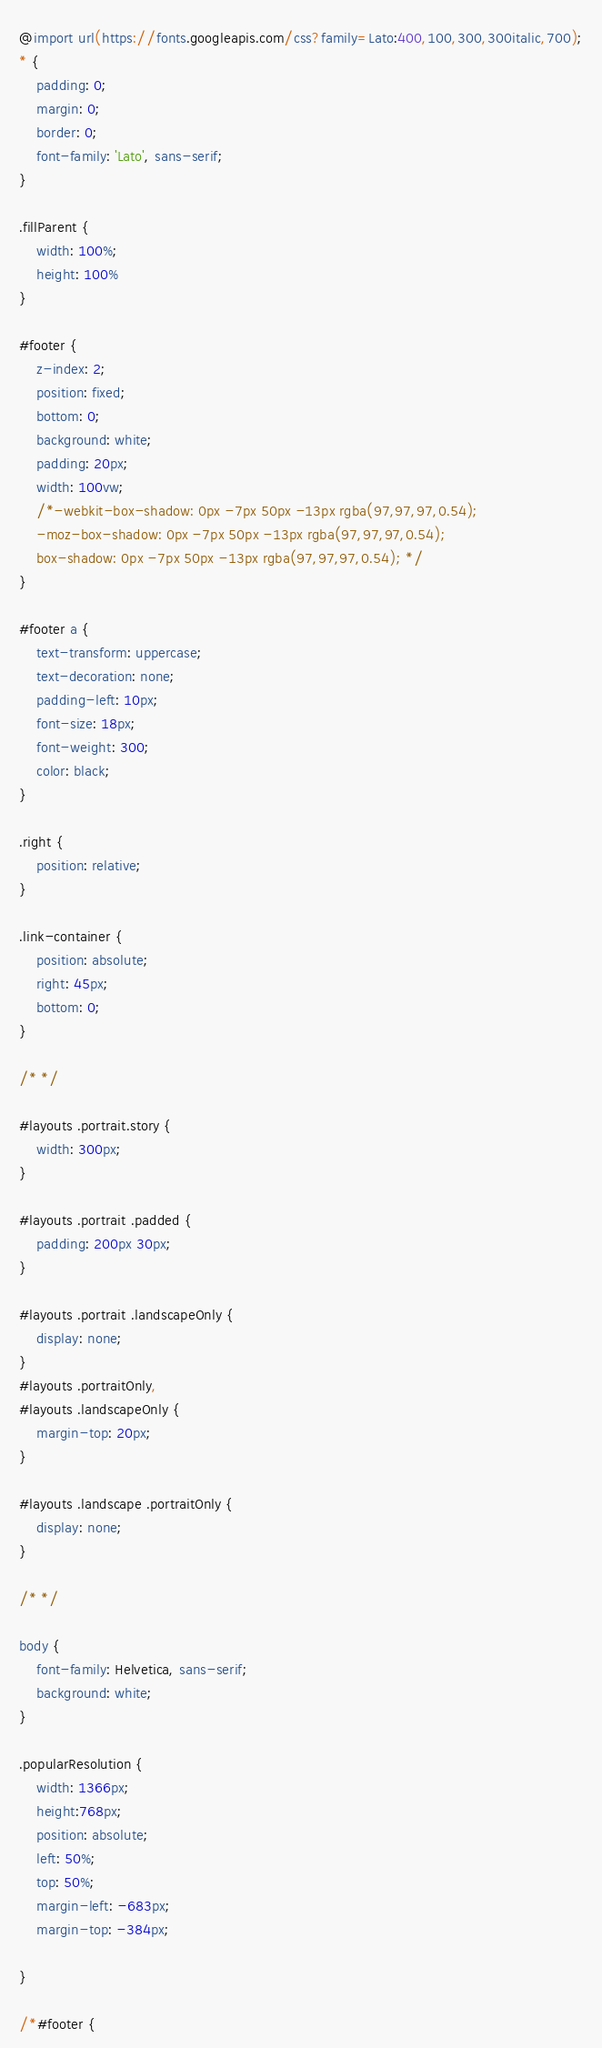Convert code to text. <code><loc_0><loc_0><loc_500><loc_500><_CSS_>@import url(https://fonts.googleapis.com/css?family=Lato:400,100,300,300italic,700);
* {
	padding: 0;
	margin: 0;
	border: 0;
	font-family: 'Lato', sans-serif;
}

.fillParent {
	width: 100%;
	height: 100%
}

#footer {
	z-index: 2;
	position: fixed;
	bottom: 0;
	background: white;
	padding: 20px;
	width: 100vw;
	/*-webkit-box-shadow: 0px -7px 50px -13px rgba(97,97,97,0.54);
	-moz-box-shadow: 0px -7px 50px -13px rgba(97,97,97,0.54);
	box-shadow: 0px -7px 50px -13px rgba(97,97,97,0.54); */
}

#footer a {
	text-transform: uppercase;
	text-decoration: none;
	padding-left: 10px;
	font-size: 18px;
	font-weight: 300;
	color: black;
}

.right {
	position: relative;
}

.link-container {
	position: absolute;
	right: 45px;
	bottom: 0;
}

/* */

#layouts .portrait.story {
	width: 300px;
}

#layouts .portrait .padded {
	padding: 200px 30px;
}

#layouts .portrait .landscapeOnly {
	display: none;
}
#layouts .portraitOnly,
#layouts .landscapeOnly {
	margin-top: 20px;
}

#layouts .landscape .portraitOnly {
	display: none;
}

/* */

body {
	font-family: Helvetica, sans-serif;
	background: white;
}

.popularResolution {
	width: 1366px;
	height:768px;
	position: absolute;
	left: 50%;
	top: 50%;
	margin-left: -683px;
	margin-top: -384px;

}

/*#footer {</code> 